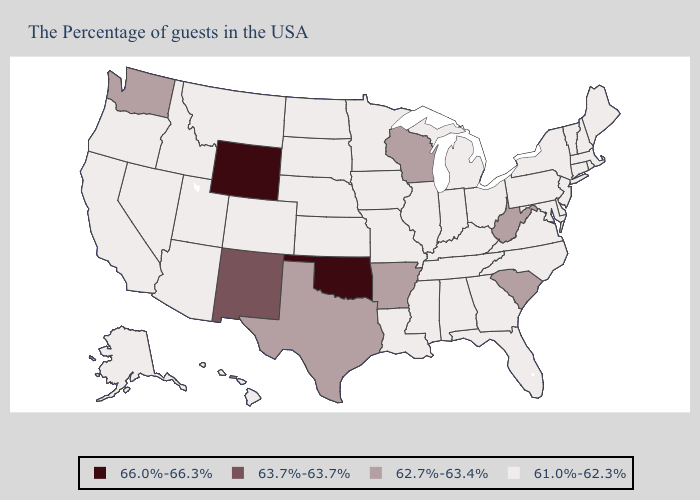What is the value of New York?
Concise answer only. 61.0%-62.3%. Does South Carolina have the lowest value in the South?
Write a very short answer. No. What is the lowest value in states that border Nevada?
Short answer required. 61.0%-62.3%. Among the states that border Louisiana , which have the highest value?
Short answer required. Arkansas, Texas. What is the value of Nebraska?
Concise answer only. 61.0%-62.3%. What is the value of Virginia?
Give a very brief answer. 61.0%-62.3%. Is the legend a continuous bar?
Write a very short answer. No. What is the highest value in the USA?
Short answer required. 66.0%-66.3%. Among the states that border Massachusetts , which have the lowest value?
Be succinct. Rhode Island, New Hampshire, Vermont, Connecticut, New York. What is the lowest value in the MidWest?
Write a very short answer. 61.0%-62.3%. Does Ohio have a lower value than West Virginia?
Concise answer only. Yes. Name the states that have a value in the range 62.7%-63.4%?
Concise answer only. South Carolina, West Virginia, Wisconsin, Arkansas, Texas, Washington. What is the value of New Hampshire?
Answer briefly. 61.0%-62.3%. Does New Mexico have the lowest value in the West?
Give a very brief answer. No. 